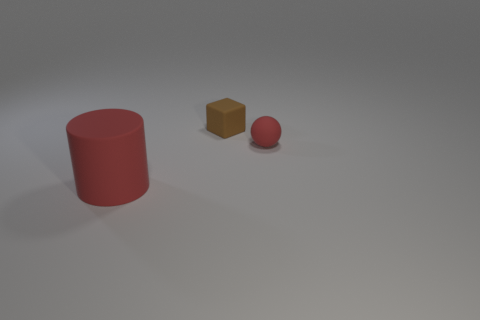How big is the rubber thing that is to the left of the tiny rubber object left of the red object behind the large red cylinder?
Offer a very short reply. Large. What number of red cylinders are made of the same material as the sphere?
Provide a short and direct response. 1. Are there fewer tiny gray cylinders than small red things?
Give a very brief answer. Yes. Does the red object that is to the right of the big red rubber object have the same material as the block?
Offer a very short reply. Yes. Is the brown matte object the same shape as the small red thing?
Ensure brevity in your answer.  No. What number of objects are red matte things behind the big rubber cylinder or large yellow rubber cylinders?
Give a very brief answer. 1. What size is the ball that is made of the same material as the red cylinder?
Your response must be concise. Small. What number of other large matte things have the same color as the big thing?
Your response must be concise. 0. How many small objects are either brown rubber cylinders or red things?
Your answer should be compact. 1. What is the size of the sphere that is the same color as the big object?
Your response must be concise. Small. 